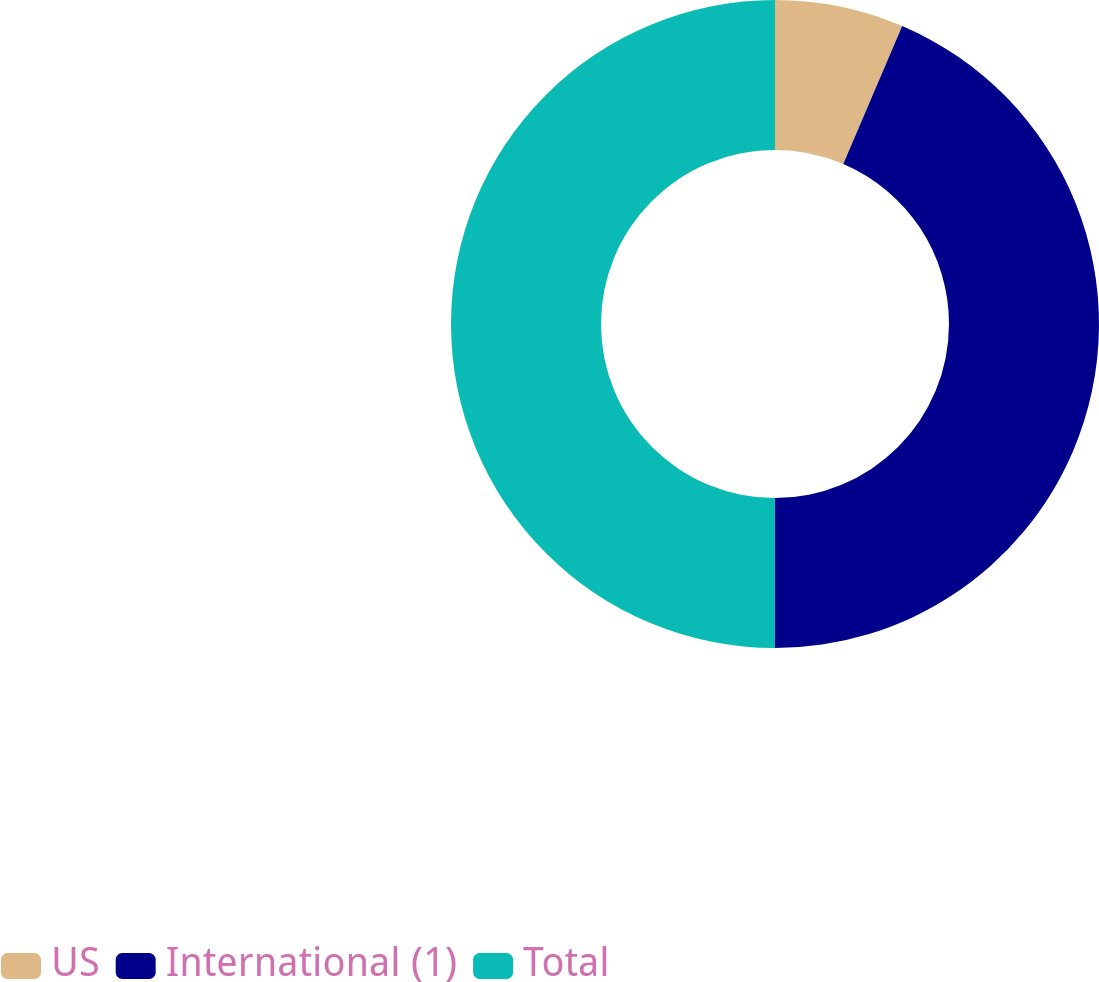Convert chart to OTSL. <chart><loc_0><loc_0><loc_500><loc_500><pie_chart><fcel>US<fcel>International (1)<fcel>Total<nl><fcel>6.42%<fcel>43.58%<fcel>50.0%<nl></chart> 